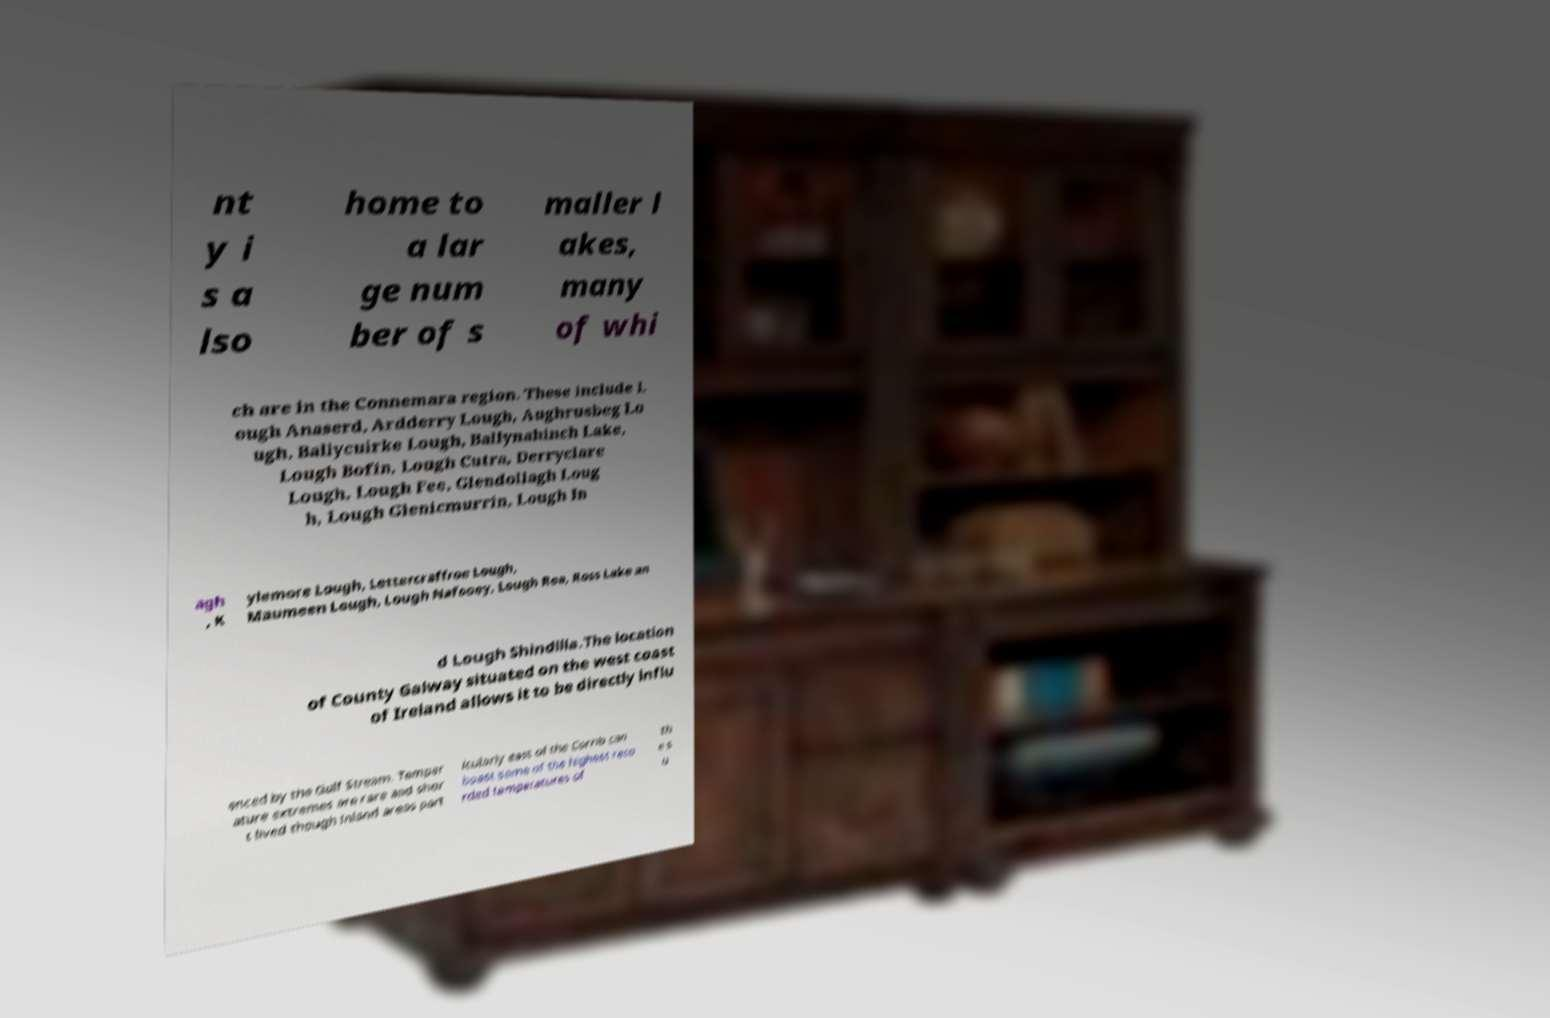Can you accurately transcribe the text from the provided image for me? nt y i s a lso home to a lar ge num ber of s maller l akes, many of whi ch are in the Connemara region. These include L ough Anaserd, Ardderry Lough, Aughrusbeg Lo ugh, Ballycuirke Lough, Ballynahinch Lake, Lough Bofin, Lough Cutra, Derryclare Lough, Lough Fee, Glendollagh Loug h, Lough Glenicmurrin, Lough In agh , K ylemore Lough, Lettercraffroe Lough, Maumeen Lough, Lough Nafooey, Lough Rea, Ross Lake an d Lough Shindilla.The location of County Galway situated on the west coast of Ireland allows it to be directly influ enced by the Gulf Stream. Temper ature extremes are rare and shor t lived though inland areas part icularly east of the Corrib can boast some of the highest reco rded temperatures of th e s u 